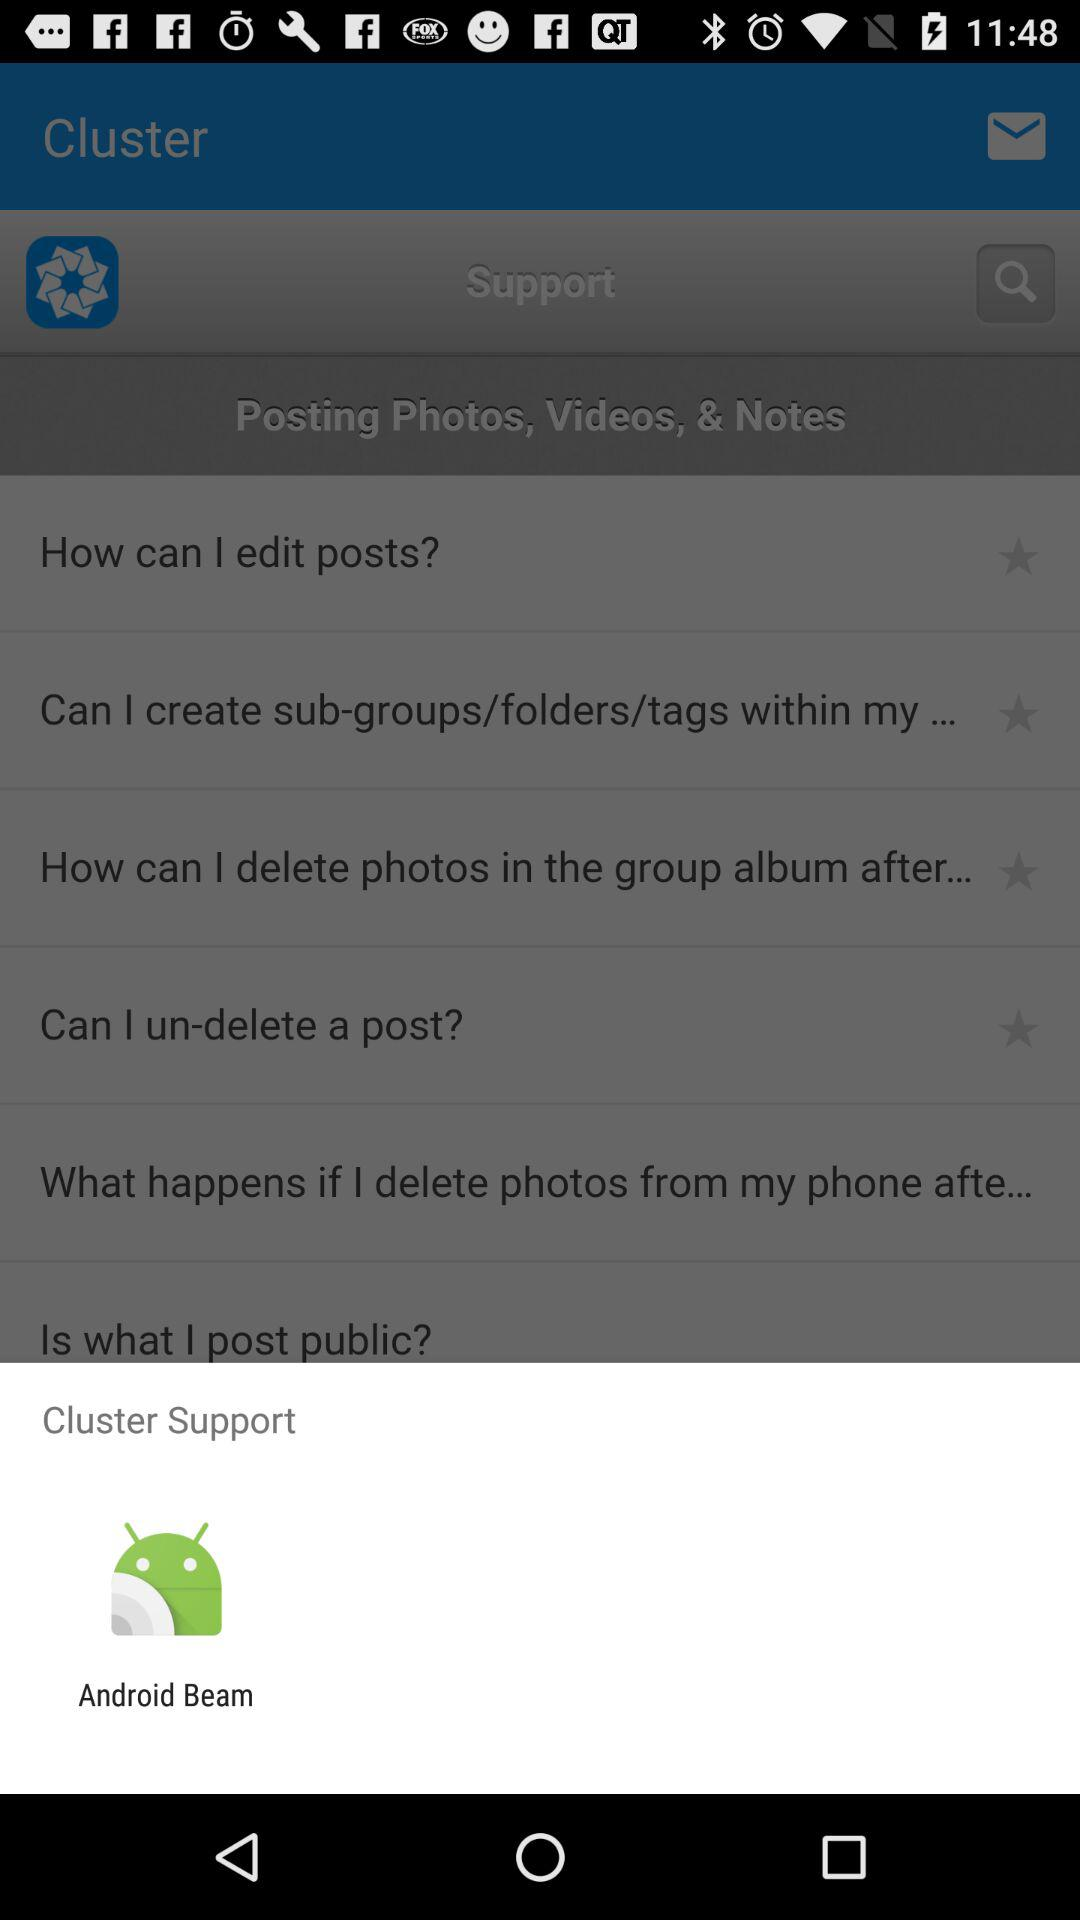What are the options for "Cluster Support"? The option is "Android Beam". 